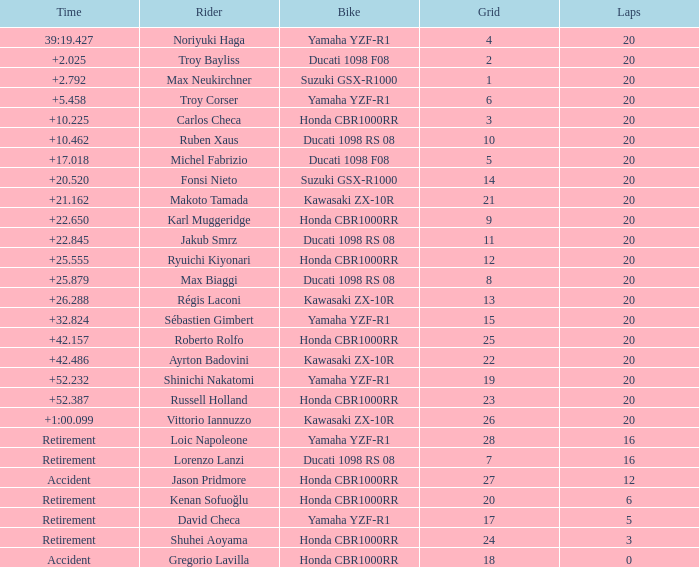What is the time of Max Biaggi with more than 2 grids, 20 laps? 25.879. 